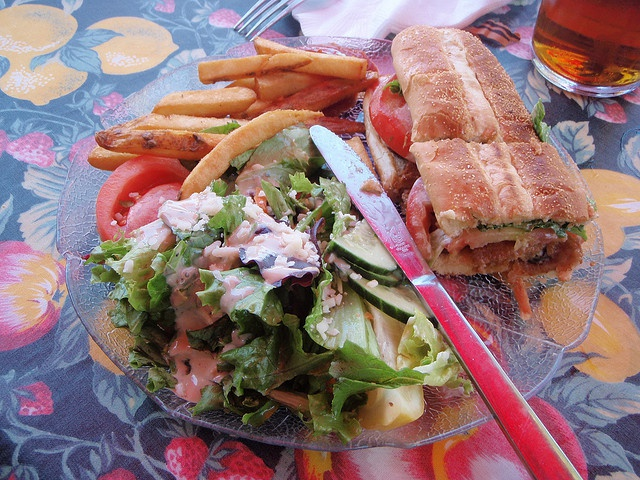Describe the objects in this image and their specific colors. I can see dining table in lightpink, brown, darkgray, lavender, and black tones, sandwich in lightblue, lightpink, brown, maroon, and lightgray tones, knife in lightblue, brown, and lavender tones, cup in lightblue, maroon, brown, and red tones, and fork in lightblue, lavender, darkgray, and gray tones in this image. 